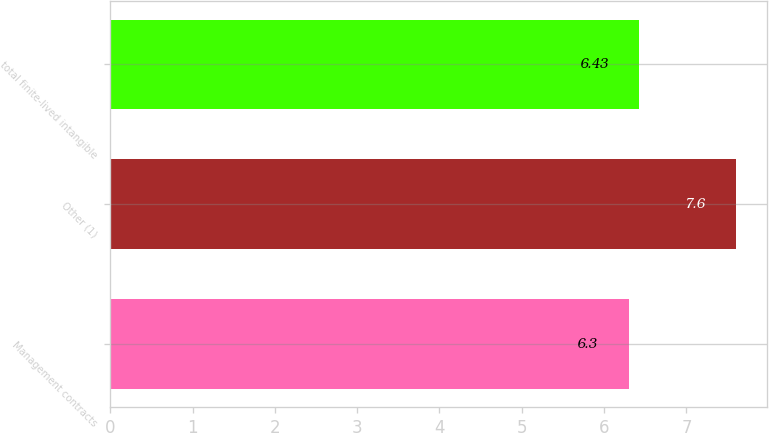Convert chart to OTSL. <chart><loc_0><loc_0><loc_500><loc_500><bar_chart><fcel>Management contracts<fcel>Other (1)<fcel>total finite-lived intangible<nl><fcel>6.3<fcel>7.6<fcel>6.43<nl></chart> 